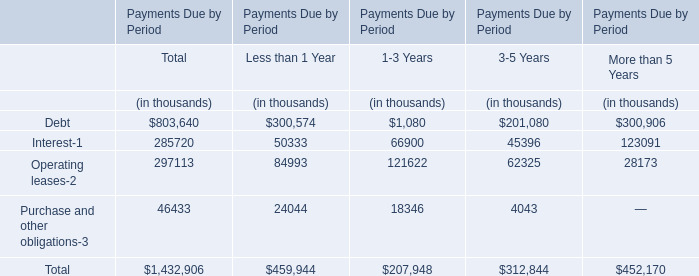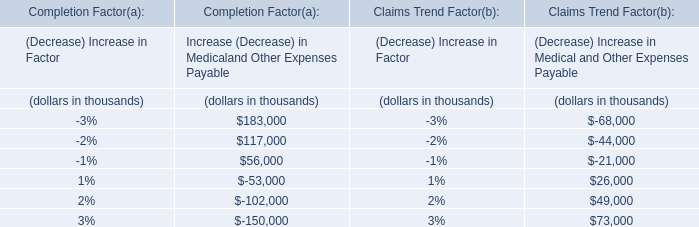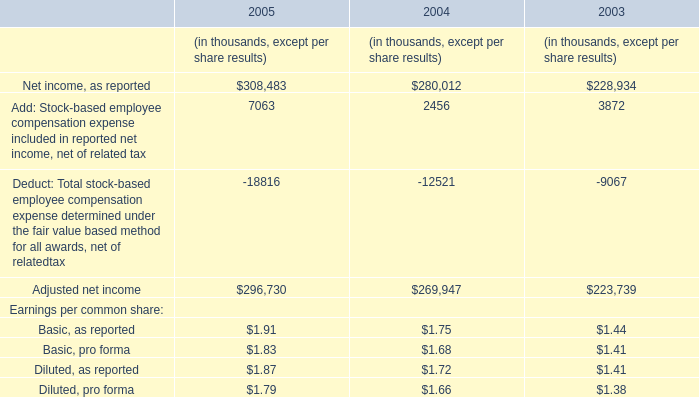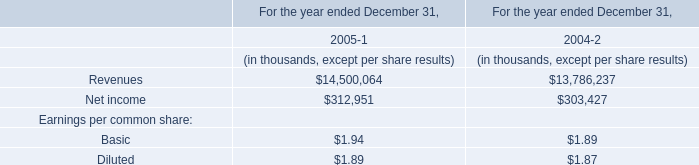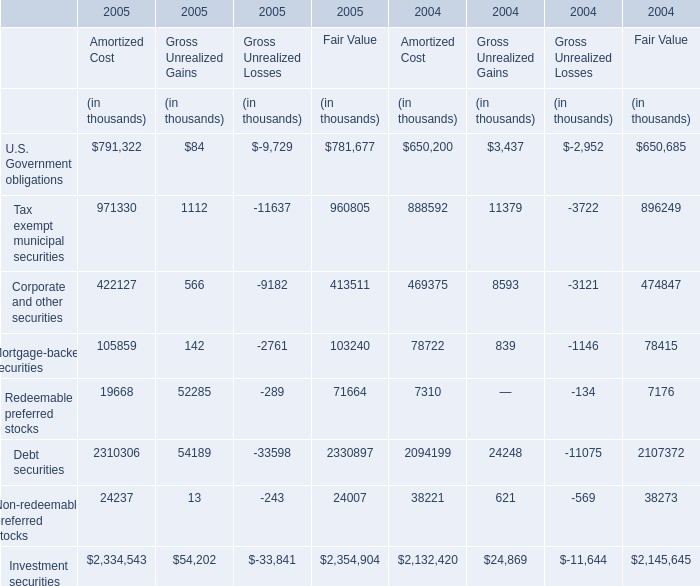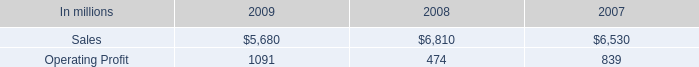What was the average of the Net income in the years where Revenues is positive? (in thousand) 
Computations: ((312951 + 303427) / 2)
Answer: 308189.0. 